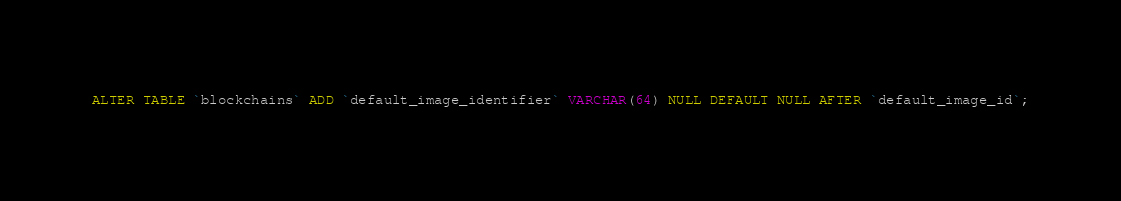Convert code to text. <code><loc_0><loc_0><loc_500><loc_500><_SQL_>ALTER TABLE `blockchains` ADD `default_image_identifier` VARCHAR(64) NULL DEFAULT NULL AFTER `default_image_id`;
</code> 